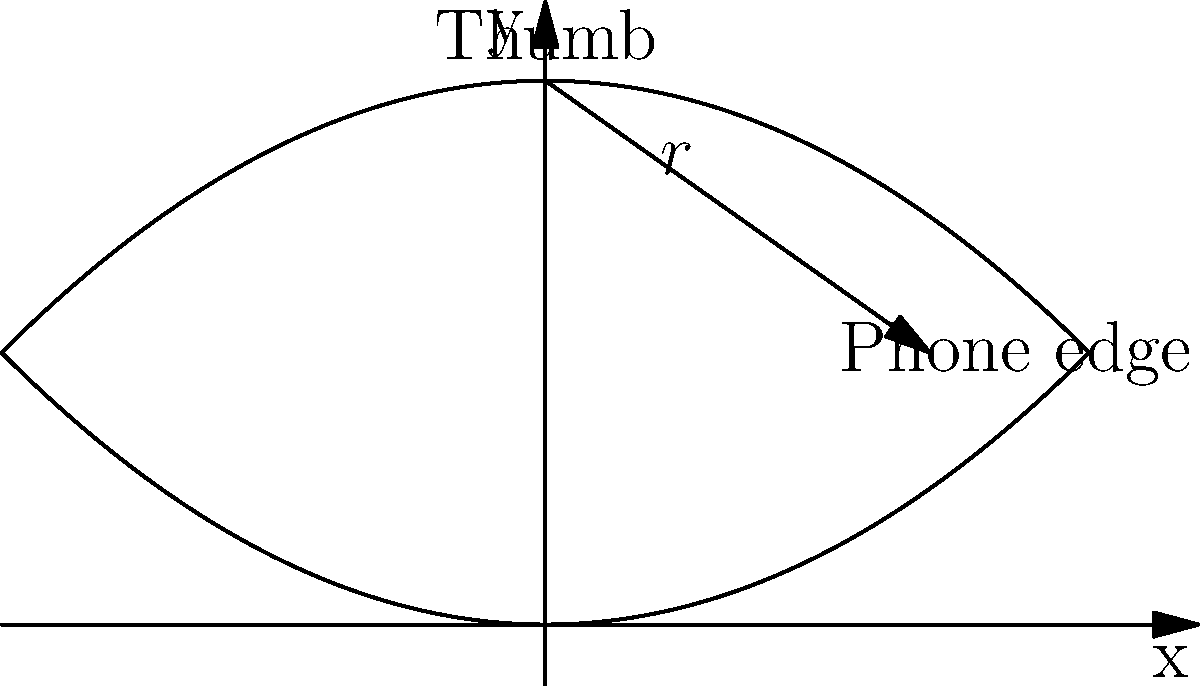As a smartphone innovator, you're designing a new model with curved edges for improved ergonomics and aesthetics. The cross-section of the phone's edge can be modeled by the parabola $y = 0.5x^2$, where $x$ and $y$ are in centimeters. If a user's thumb comfort zone is represented by the curve $y = 1 - 0.5x^2$, what is the optimal radius of curvature $r$ (in cm) for the phone's edge at the point of contact with the user's thumb to maximize both comfort and visual appeal? To solve this problem, we'll follow these steps:

1) The point of contact between the phone's edge and the user's thumb occurs where the two curves intersect. To find this, we equate the two functions:

   $0.5x^2 = 1 - 0.5x^2$

2) Solving this equation:
   $x^2 = 1$
   $x = \pm 1$

   We'll use the positive solution, $x = 1$.

3) The y-coordinate at this point is:
   $y = 0.5(1)^2 = 0.5$

   So the point of contact is $(1, 0.5)$.

4) The radius of curvature for a curve $y = f(x)$ at any point is given by:

   $r = \frac{(1 + (f'(x))^2)^{3/2}}{|f''(x)|}$

5) For our curve $y = 0.5x^2$:
   $f'(x) = x$
   $f''(x) = 1$

6) Substituting $x = 1$ and these derivatives into the radius of curvature formula:

   $r = \frac{(1 + (1)^2)^{3/2}}{|1|}$

7) Simplifying:
   $r = \frac{2^{3/2}}{1} = 2\sqrt{2} \approx 2.83$ cm

This radius of curvature provides the optimal balance between ergonomics (fitting the user's thumb) and aesthetics (maintaining a sleek curve) at the point of contact.
Answer: $2\sqrt{2}$ cm 